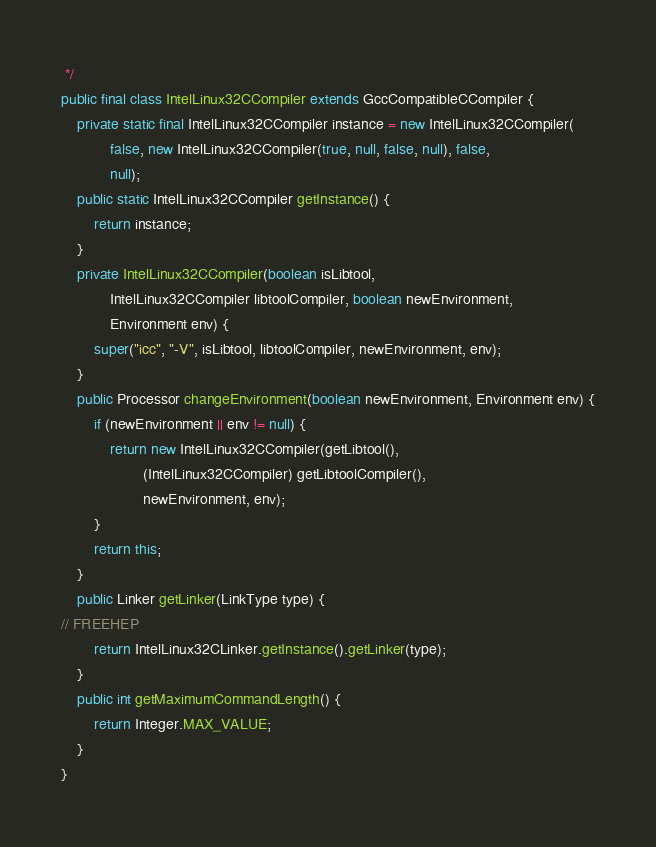<code> <loc_0><loc_0><loc_500><loc_500><_Java_> */
public final class IntelLinux32CCompiler extends GccCompatibleCCompiler {
    private static final IntelLinux32CCompiler instance = new IntelLinux32CCompiler(
            false, new IntelLinux32CCompiler(true, null, false, null), false,
            null);
    public static IntelLinux32CCompiler getInstance() {
        return instance;
    }
    private IntelLinux32CCompiler(boolean isLibtool,
            IntelLinux32CCompiler libtoolCompiler, boolean newEnvironment,
            Environment env) {
        super("icc", "-V", isLibtool, libtoolCompiler, newEnvironment, env);
    }
    public Processor changeEnvironment(boolean newEnvironment, Environment env) {
        if (newEnvironment || env != null) {
            return new IntelLinux32CCompiler(getLibtool(),
                    (IntelLinux32CCompiler) getLibtoolCompiler(),
                    newEnvironment, env);
        }
        return this;
    }
    public Linker getLinker(LinkType type) {
// FREEHEP
        return IntelLinux32CLinker.getInstance().getLinker(type);
    }
    public int getMaximumCommandLength() {
        return Integer.MAX_VALUE;
    }
}
</code> 